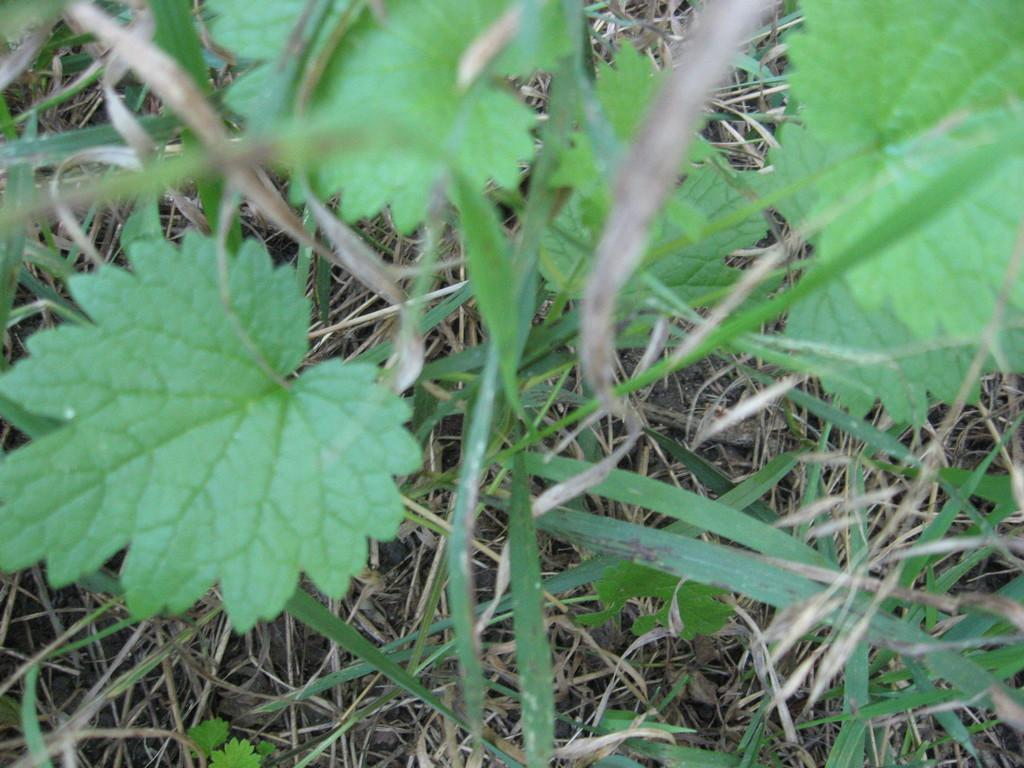What type of vegetation can be seen in the image? There is dried grass and leaves of a plant in the image. Can you describe the condition of the vegetation? The grass appears to be dried, and the leaves are likely from a plant. What is the source of anger in the image? There is no indication of anger or any emotional state in the image; it only features dried grass and leaves of a plant. 